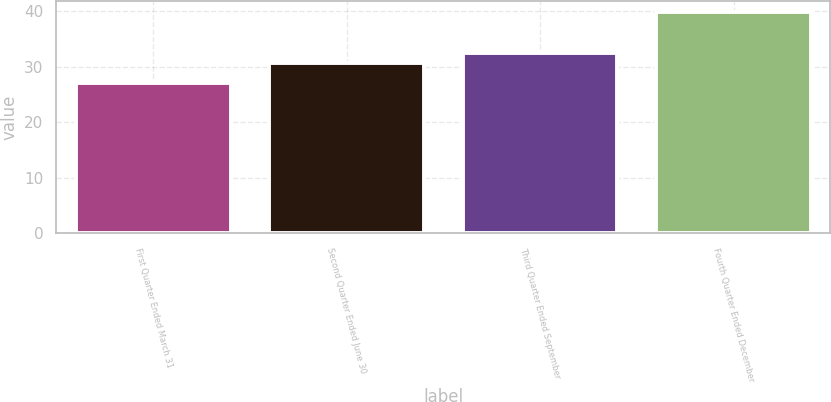<chart> <loc_0><loc_0><loc_500><loc_500><bar_chart><fcel>First Quarter Ended March 31<fcel>Second Quarter Ended June 30<fcel>Third Quarter Ended September<fcel>Fourth Quarter Ended December<nl><fcel>27.02<fcel>30.7<fcel>32.54<fcel>39.93<nl></chart> 